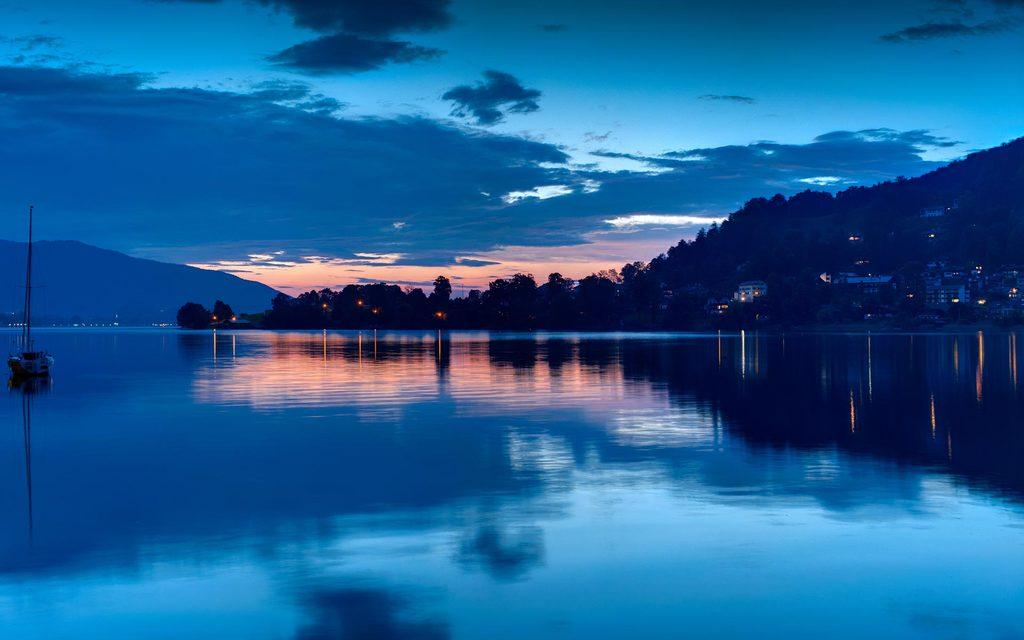What is the main subject of the image? The main subject of the image is a boat. Where is the boat located? The boat is on the water. What can be seen on the right side of the boat? There are buildings, trees, and lights on the right side of the boat. What is visible behind the boat? There is a hill visible behind the boat. What is visible in the sky in the image? The sky is visible in the image. What type of flowers can be seen growing on the boat in the image? There are no flowers visible on the boat in the image. What class is the boat used for in the image? The image does not provide information about the boat's class or purpose. 